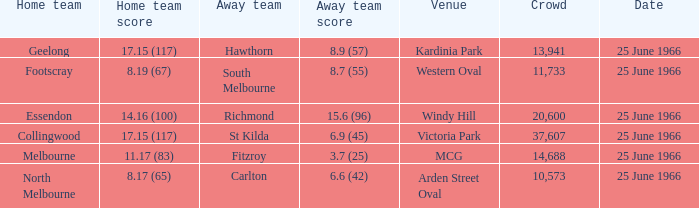When a home team scored 17.15 (117) and the away team scored 6.9 (45), what was the away team? St Kilda. 